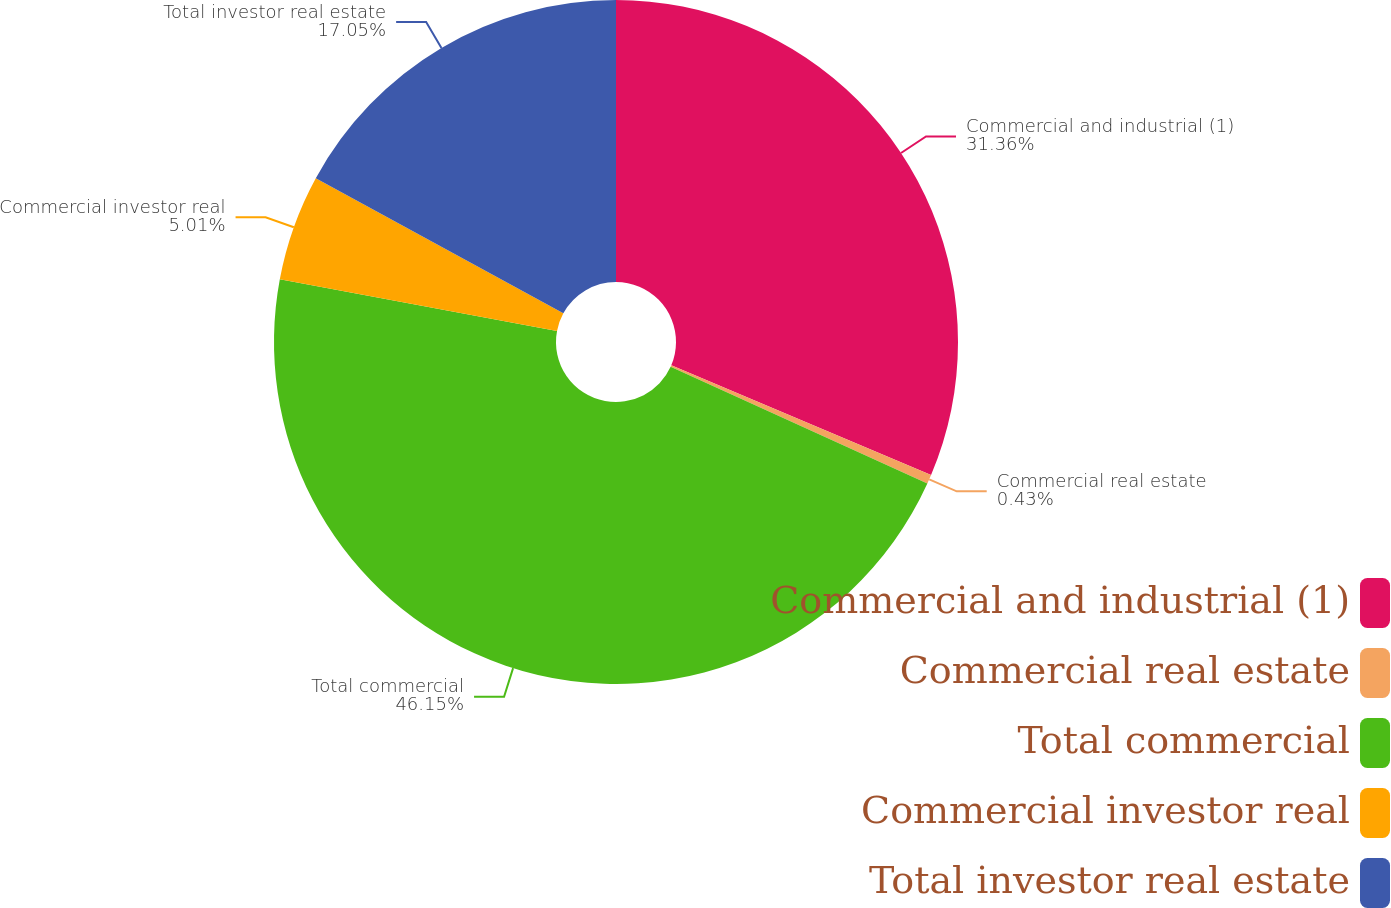<chart> <loc_0><loc_0><loc_500><loc_500><pie_chart><fcel>Commercial and industrial (1)<fcel>Commercial real estate<fcel>Total commercial<fcel>Commercial investor real<fcel>Total investor real estate<nl><fcel>31.36%<fcel>0.43%<fcel>46.15%<fcel>5.01%<fcel>17.05%<nl></chart> 